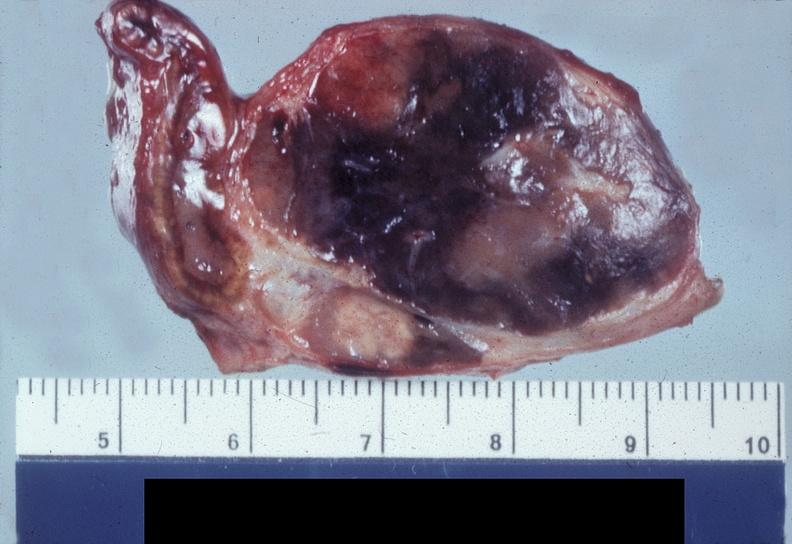s endocrine present?
Answer the question using a single word or phrase. Yes 